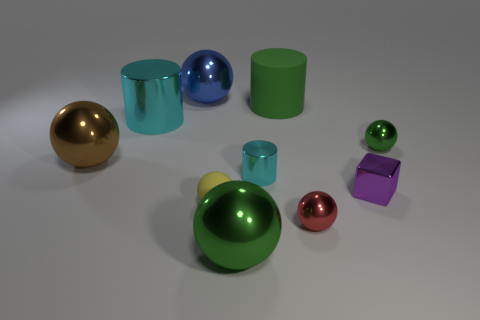There is a green object that is the same size as the red sphere; what is its shape?
Make the answer very short. Sphere. The sphere that is behind the tiny red sphere and right of the big green metallic sphere is what color?
Offer a very short reply. Green. Does the big ball that is on the right side of the big blue shiny thing have the same material as the red object?
Your answer should be compact. Yes. Are there fewer small spheres that are behind the small matte ball than small yellow shiny balls?
Offer a very short reply. No. Are there any large brown cylinders that have the same material as the purple thing?
Offer a terse response. No. Is the size of the cube the same as the green shiny object behind the red shiny ball?
Provide a short and direct response. Yes. Are there any big balls of the same color as the large rubber cylinder?
Provide a short and direct response. Yes. Do the big green sphere and the brown object have the same material?
Give a very brief answer. Yes. How many things are to the right of the tiny purple metallic object?
Your response must be concise. 1. What is the material of the large thing that is to the right of the large brown sphere and on the left side of the large blue sphere?
Your answer should be compact. Metal. 